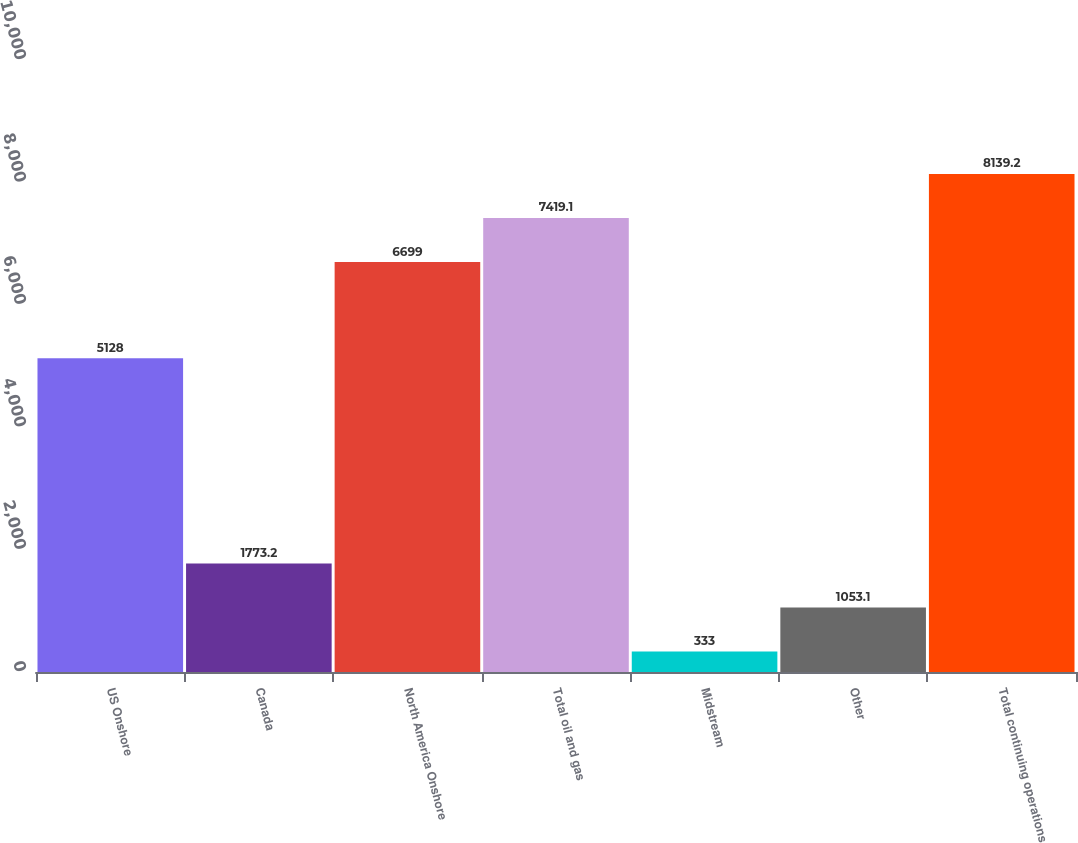Convert chart to OTSL. <chart><loc_0><loc_0><loc_500><loc_500><bar_chart><fcel>US Onshore<fcel>Canada<fcel>North America Onshore<fcel>Total oil and gas<fcel>Midstream<fcel>Other<fcel>Total continuing operations<nl><fcel>5128<fcel>1773.2<fcel>6699<fcel>7419.1<fcel>333<fcel>1053.1<fcel>8139.2<nl></chart> 